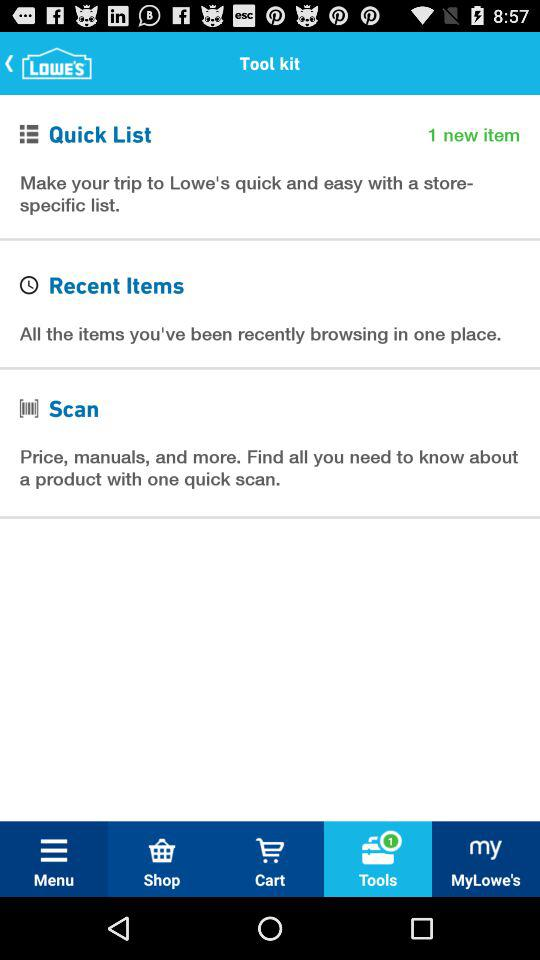How many pop-ups are in "Tools"? There is one pop up in "Tools". 